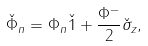<formula> <loc_0><loc_0><loc_500><loc_500>\check { \Phi } _ { n } = \Phi _ { n } \check { 1 } + \frac { \Phi ^ { - } } { 2 } \check { \sigma } _ { z } ,</formula> 